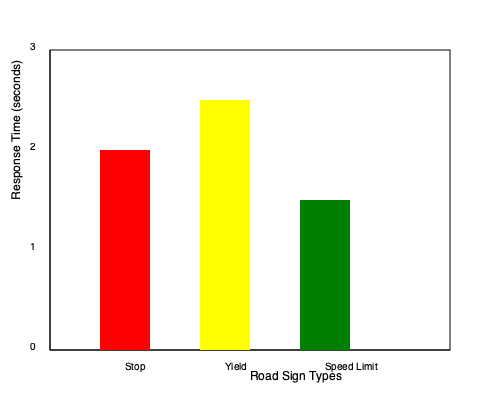Based on the bar chart showing driver response times to different types of road signs, which sign type appears to be the most effective in terms of eliciting the quickest response from drivers, and what implications might this have for traffic safety planning? To answer this question, we need to analyze the bar chart and interpret the data:

1. Identify the variables:
   - X-axis: Road Sign Types (Stop, Yield, Speed Limit)
   - Y-axis: Response Time (in seconds)

2. Compare the heights of the bars:
   - Stop sign (red): approximately 2 seconds
   - Yield sign (yellow): approximately 2.5 seconds
   - Speed Limit sign (green): approximately 1.5 seconds

3. Interpret the data:
   - Lower response times indicate quicker reactions from drivers
   - The Speed Limit sign has the shortest bar, representing the quickest response time

4. Consider the implications for traffic safety planning:
   - Quicker response times generally lead to safer driving conditions
   - The effectiveness of Speed Limit signs suggests they may be particularly useful in areas requiring rapid driver attention and adjustment
   - However, the nature of the required response (slowing down vs. stopping) should also be considered
   - Stop and Yield signs, despite longer response times, may still be crucial for specific traffic control scenarios

5. Conclusion:
   The Speed Limit sign appears to be the most effective in eliciting quick responses from drivers. This suggests that clear, numerical information may be processed more rapidly by drivers, which could be valuable for traffic safety planning in areas where quick speed adjustments are necessary.
Answer: Speed Limit signs; potential for improved safety through quicker driver responses in speed-critical areas. 